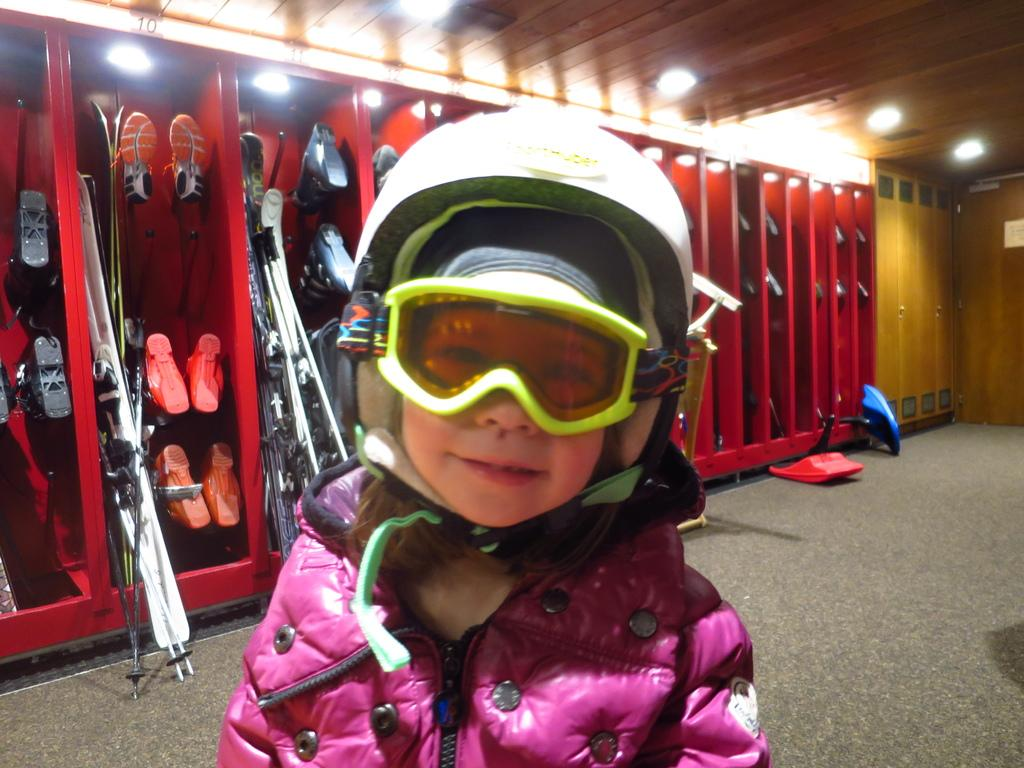What is the main subject of the image? There is a person in the image. What is the person doing in the image? The person is standing. What color is the jacket the person is wearing? The person is wearing a pink jacket. What type of headgear is the person wearing? The person is wearing a white helmet. What can be seen in the background of the image? There are shoes and lights visible in the background. How many men are playing baseball in the image? There is no baseball game or men playing baseball present in the image. 